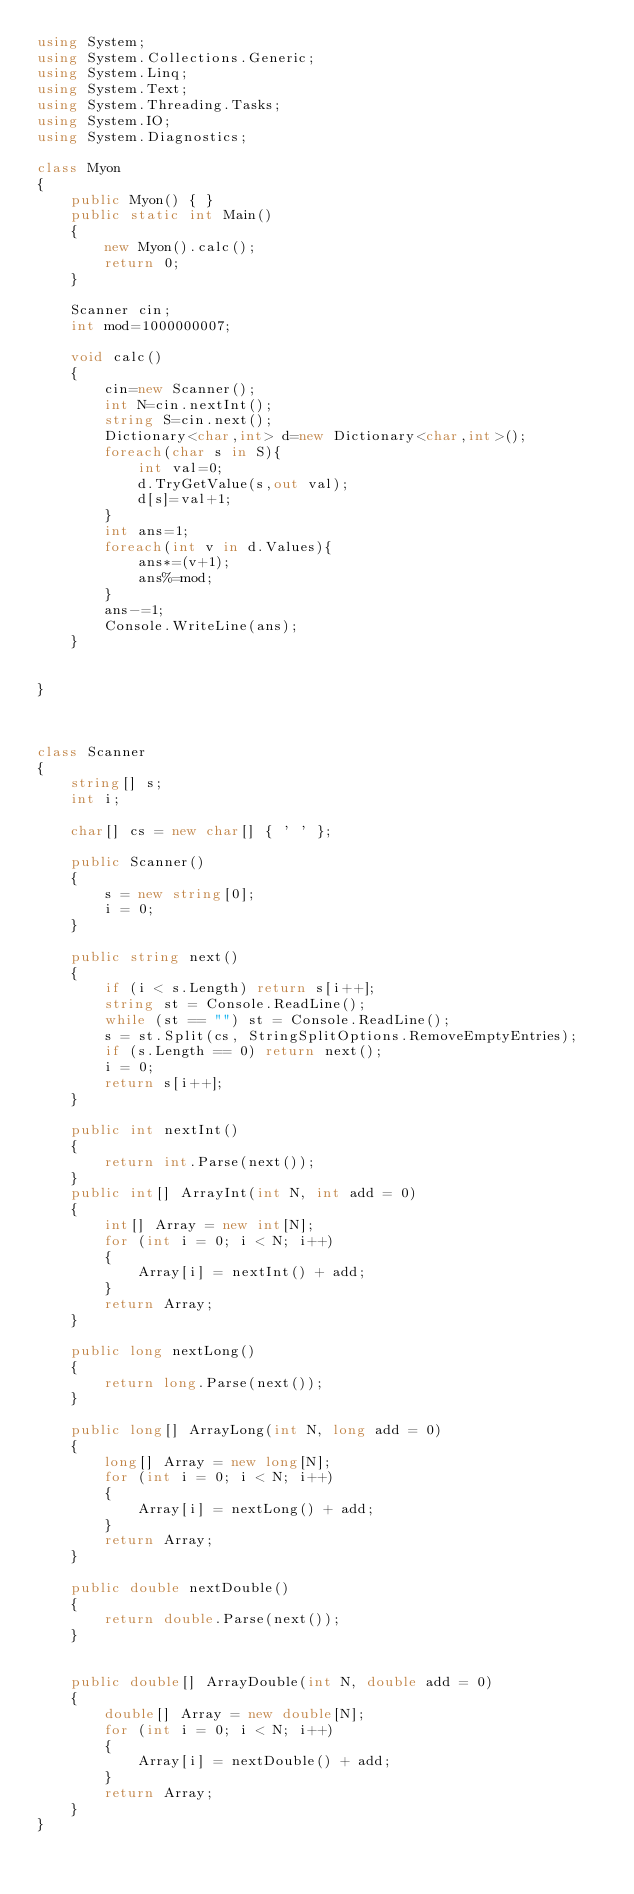Convert code to text. <code><loc_0><loc_0><loc_500><loc_500><_C#_>using System;
using System.Collections.Generic;
using System.Linq;
using System.Text;
using System.Threading.Tasks;
using System.IO;
using System.Diagnostics;

class Myon
{
    public Myon() { }
    public static int Main()
    {
        new Myon().calc();
        return 0;
    }

    Scanner cin;
    int mod=1000000007;

    void calc()
    {
        cin=new Scanner();
        int N=cin.nextInt();
        string S=cin.next();
        Dictionary<char,int> d=new Dictionary<char,int>();
        foreach(char s in S){
            int val=0;
            d.TryGetValue(s,out val);
            d[s]=val+1;
        }
        int ans=1;
        foreach(int v in d.Values){
            ans*=(v+1);
            ans%=mod;
        }
        ans-=1;
        Console.WriteLine(ans);
    }


}



class Scanner
{
    string[] s;
    int i;

    char[] cs = new char[] { ' ' };

    public Scanner()
    {
        s = new string[0];
        i = 0;
    }

    public string next()
    {
        if (i < s.Length) return s[i++];
        string st = Console.ReadLine();
        while (st == "") st = Console.ReadLine();
        s = st.Split(cs, StringSplitOptions.RemoveEmptyEntries);
        if (s.Length == 0) return next();
        i = 0;
        return s[i++];
    }

    public int nextInt()
    {
        return int.Parse(next());
    }
    public int[] ArrayInt(int N, int add = 0)
    {
        int[] Array = new int[N];
        for (int i = 0; i < N; i++)
        {
            Array[i] = nextInt() + add;
        }
        return Array;
    }

    public long nextLong()
    {
        return long.Parse(next());
    }

    public long[] ArrayLong(int N, long add = 0)
    {
        long[] Array = new long[N];
        for (int i = 0; i < N; i++)
        {
            Array[i] = nextLong() + add;
        }
        return Array;
    }

    public double nextDouble()
    {
        return double.Parse(next());
    }


    public double[] ArrayDouble(int N, double add = 0)
    {
        double[] Array = new double[N];
        for (int i = 0; i < N; i++)
        {
            Array[i] = nextDouble() + add;
        }
        return Array;
    }
}
</code> 